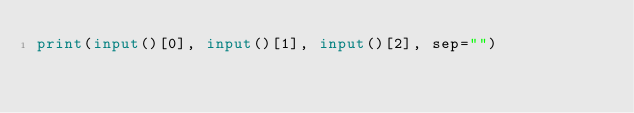Convert code to text. <code><loc_0><loc_0><loc_500><loc_500><_Python_>print(input()[0], input()[1], input()[2], sep="")</code> 